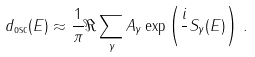Convert formula to latex. <formula><loc_0><loc_0><loc_500><loc_500>d _ { \text {osc} } ( E ) \approx \frac { 1 } { \pi } \Re \sum _ { \gamma } A _ { \gamma } \exp \left ( \frac { i } { } S _ { \gamma } ( E ) \right ) \, .</formula> 